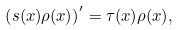Convert formula to latex. <formula><loc_0><loc_0><loc_500><loc_500>\left ( s ( x ) \rho ( x ) \right ) ^ { \prime } = \tau ( x ) \rho ( x ) ,</formula> 